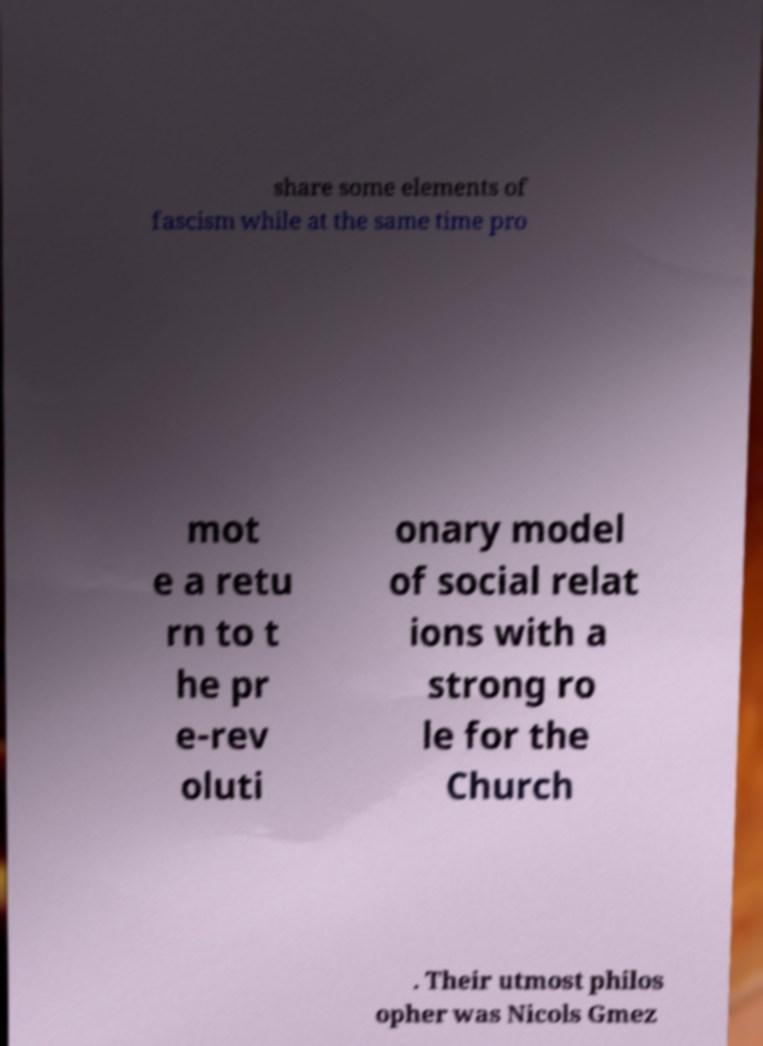Can you accurately transcribe the text from the provided image for me? share some elements of fascism while at the same time pro mot e a retu rn to t he pr e-rev oluti onary model of social relat ions with a strong ro le for the Church . Their utmost philos opher was Nicols Gmez 